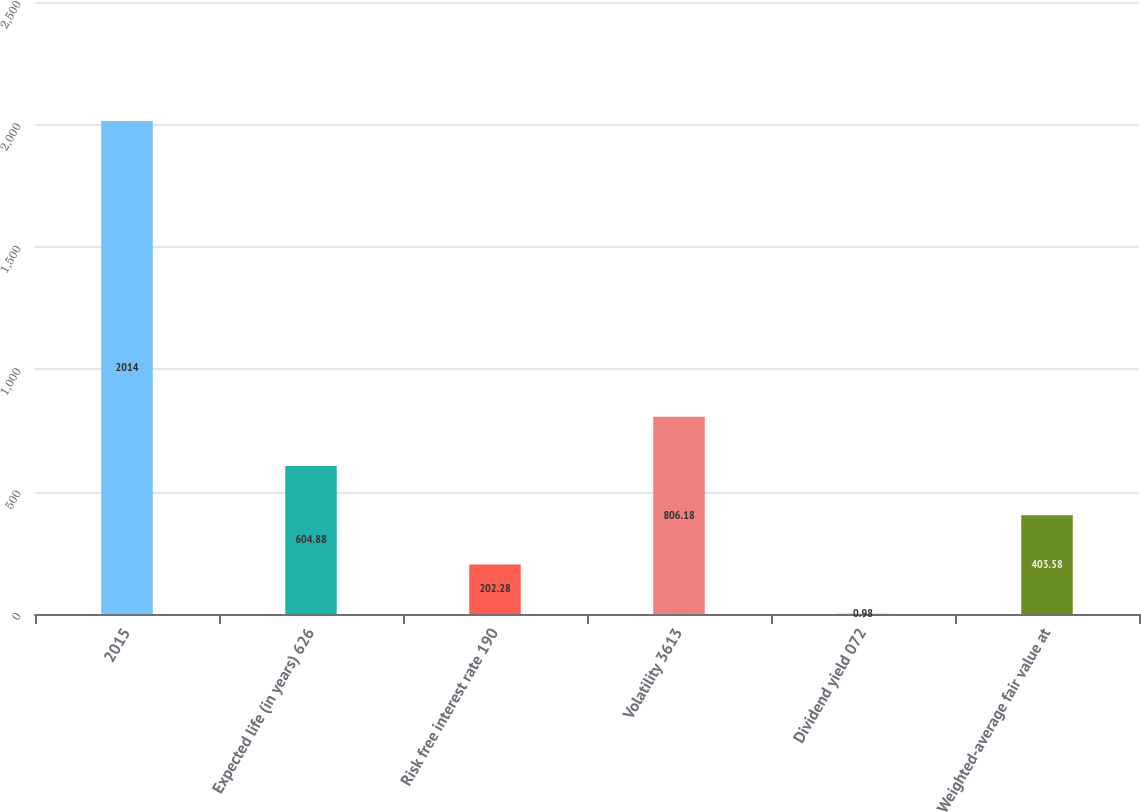Convert chart to OTSL. <chart><loc_0><loc_0><loc_500><loc_500><bar_chart><fcel>2015<fcel>Expected life (in years) 626<fcel>Risk free interest rate 190<fcel>Volatility 3613<fcel>Dividend yield 072<fcel>Weighted-average fair value at<nl><fcel>2014<fcel>604.88<fcel>202.28<fcel>806.18<fcel>0.98<fcel>403.58<nl></chart> 